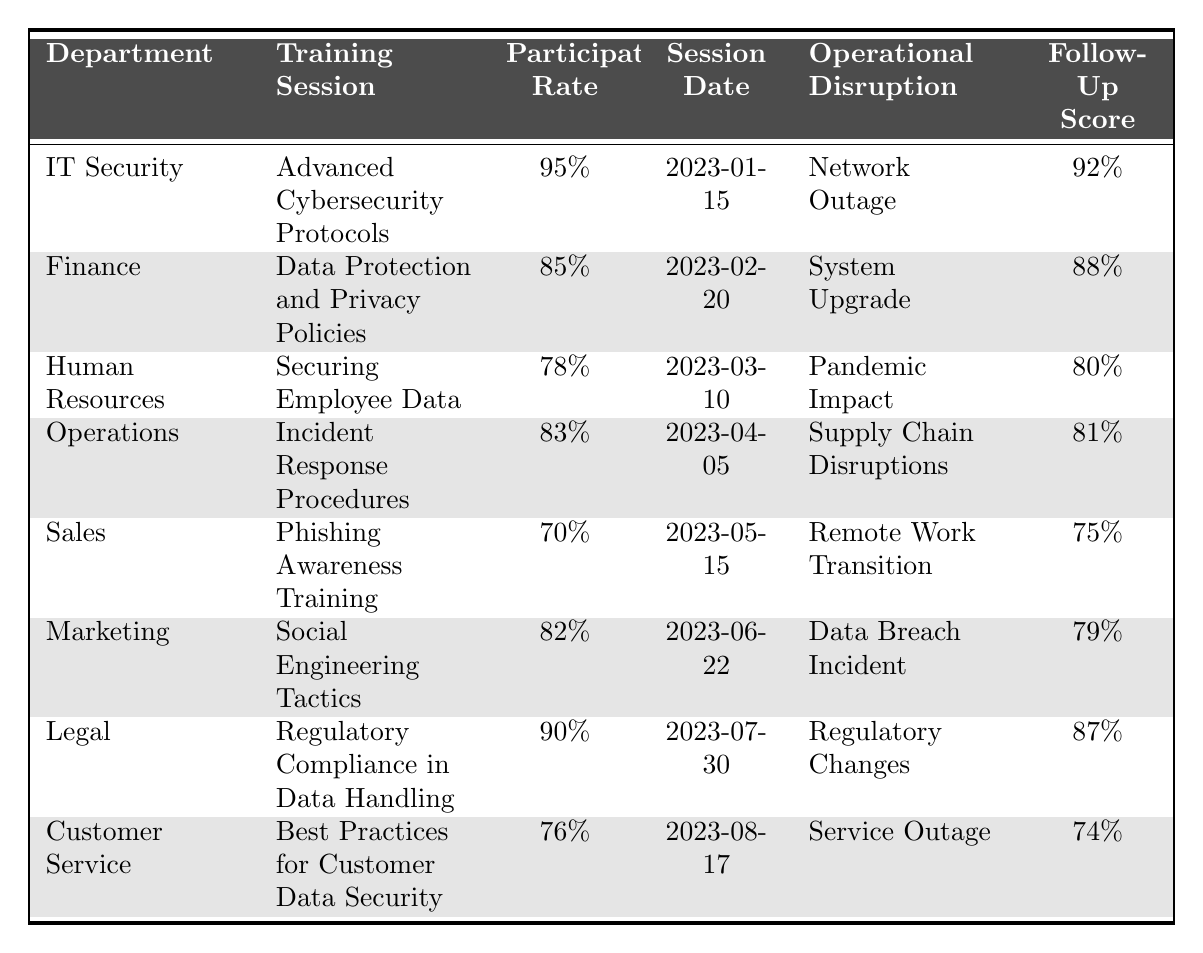What is the participation rate of the IT Security department? The participation rate for the IT Security department is specifically listed in the table as 95%.
Answer: 95% Which department had the lowest participation rate? By comparing the participation rates listed in the table, the Sales department has the lowest participation rate at 70%.
Answer: Sales What was the follow-up assessment score for the Marketing department? The follow-up assessment score for the Marketing department is found in the table as 79%.
Answer: 79% How many departments participated in training sessions related to a data breach? The Marketing department had a training session related to a data breach, so only 1 department is noted in the table for this specific context.
Answer: 1 Is the participation rate for the Finance department greater than 80%? The table shows the Finance department's participation rate as 85%, which is indeed greater than 80%.
Answer: Yes What is the average participation rate across all departments listed? The participation rates are: 95%, 85%, 78%, 83%, 70%, 82%, 90%, and 76%. Adding these gives  789%, and then dividing by 8 (the number of departments) yields an average participation rate of 98.625%, which can be rounded to 81.125%.
Answer: 81.125% Which operational disruption had the highest follow-up assessment score? The follow-up scores for each operational disruption must be evaluated: 92%, 88%, 80%, 81%, 75%, 79%, 87%, and 74%. The highest score is 92% for the Network Outage.
Answer: Network Outage Were there any training sessions conducted during a service outage? Reviewing the table, the Customer Service department conducted a training session during a service outage.
Answer: Yes What is the difference between the highest and lowest follow-up assessment scores? The highest follow-up score is 92% (IT Security) and the lowest is 74% (Customer Service). The difference is 92% - 74% = 18%.
Answer: 18% If we consider training participation rates only from departments that went through "Operational Disruptions," what is the median participation rate? The relevant departments and their participation rates are: 95% (IT Security), 85% (Finance), 78% (HR), 83% (Operations), 70% (Sales), 82% (Marketing), 90% (Legal), and 76% (Customer Service). Sorting these gives 70%, 76%, 78%, 82%, 83%, 85%, 90%, 95%. The median (the average of the 4th and 5th values) is (82% + 83%) / 2 = 82.5%.
Answer: 82.5% 